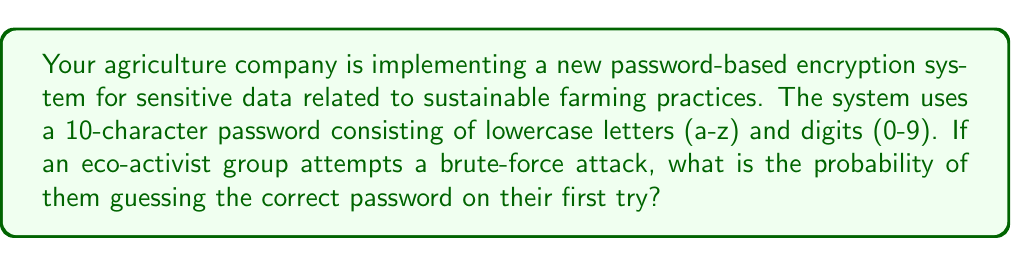Show me your answer to this math problem. To solve this problem, we need to follow these steps:

1. Determine the total number of possible characters:
   - 26 lowercase letters (a-z)
   - 10 digits (0-9)
   Total: 26 + 10 = 36 possible characters

2. Calculate the total number of possible passwords:
   - Each character position has 36 possibilities
   - The password is 10 characters long
   - Total number of possible passwords = $36^{10}$

3. Calculate the probability of guessing the correct password on the first try:
   - Probability = $\frac{1}{\text{Total number of possible passwords}}$
   - Probability = $\frac{1}{36^{10}}$

4. Simplify the fraction:
   $$ \frac{1}{36^{10}} = \frac{1}{3,656,158,440,062,976} $$

Therefore, the probability of guessing the correct password on the first try is $\frac{1}{3,656,158,440,062,976}$ or approximately $2.73 \times 10^{-16}$.
Answer: $\frac{1}{3,656,158,440,062,976}$ 